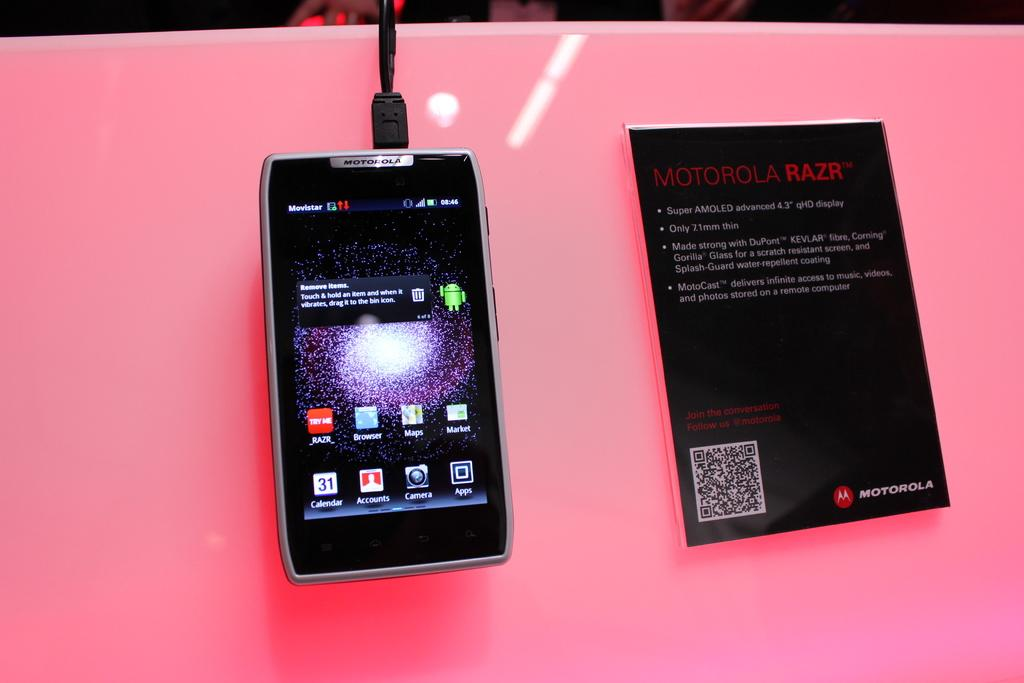Provide a one-sentence caption for the provided image. A phone is displayed next to a sign describing motorola razr. 